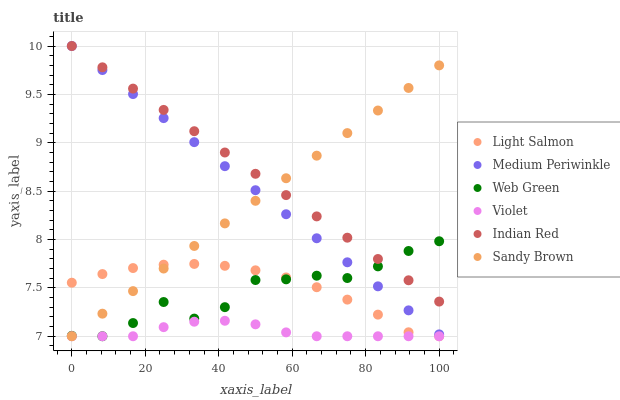Does Violet have the minimum area under the curve?
Answer yes or no. Yes. Does Indian Red have the maximum area under the curve?
Answer yes or no. Yes. Does Medium Periwinkle have the minimum area under the curve?
Answer yes or no. No. Does Medium Periwinkle have the maximum area under the curve?
Answer yes or no. No. Is Sandy Brown the smoothest?
Answer yes or no. Yes. Is Web Green the roughest?
Answer yes or no. Yes. Is Medium Periwinkle the smoothest?
Answer yes or no. No. Is Medium Periwinkle the roughest?
Answer yes or no. No. Does Light Salmon have the lowest value?
Answer yes or no. Yes. Does Medium Periwinkle have the lowest value?
Answer yes or no. No. Does Indian Red have the highest value?
Answer yes or no. Yes. Does Web Green have the highest value?
Answer yes or no. No. Is Light Salmon less than Indian Red?
Answer yes or no. Yes. Is Medium Periwinkle greater than Light Salmon?
Answer yes or no. Yes. Does Web Green intersect Violet?
Answer yes or no. Yes. Is Web Green less than Violet?
Answer yes or no. No. Is Web Green greater than Violet?
Answer yes or no. No. Does Light Salmon intersect Indian Red?
Answer yes or no. No. 